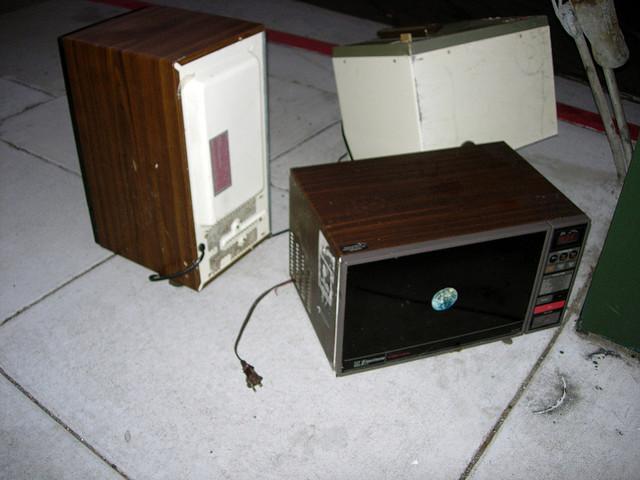What is this a picture of?
Answer briefly. Microwave. Is the equipment plugged in?
Write a very short answer. No. In what year would you estimate this equipment was bought?
Quick response, please. 1980. 